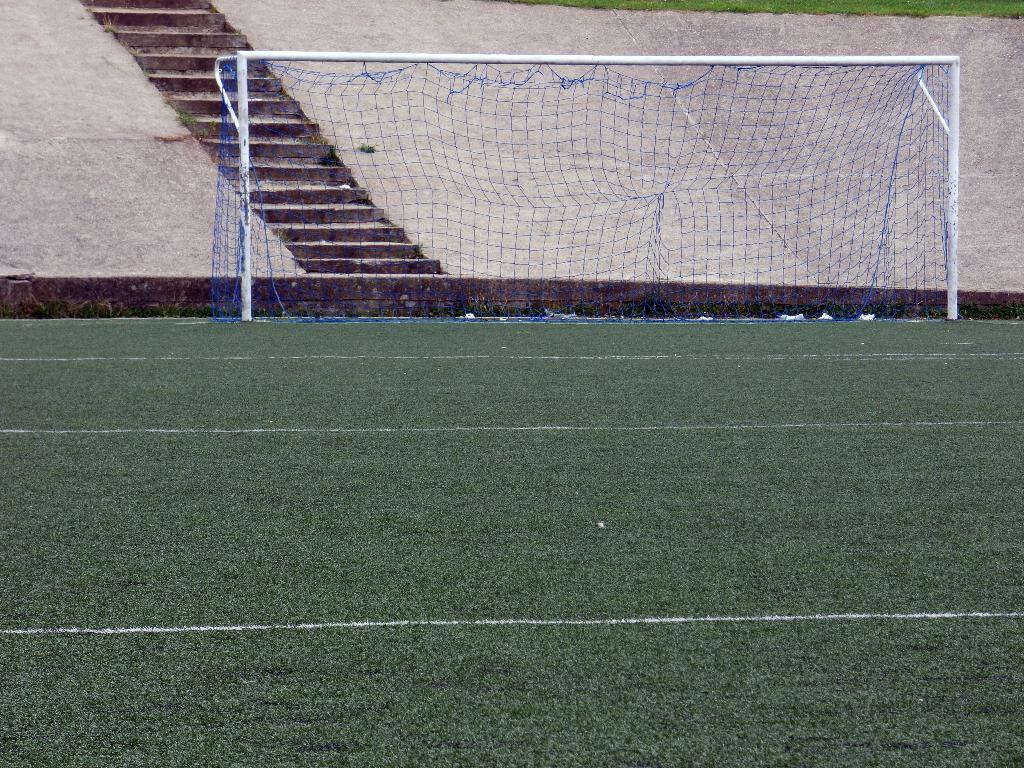What is the color of the surface in the image? The surface in the image is green. What type of material is visible in the image? There is a mesh visible in the image. What is located behind the mesh? There is a wall behind the mesh. What architectural feature can be seen in the image? There are steps in the image. What type of thunder can be heard in the image? There is no sound, including thunder, present in the image. How many cakes are visible on the green surface in the image? There are no cakes present in the image. 